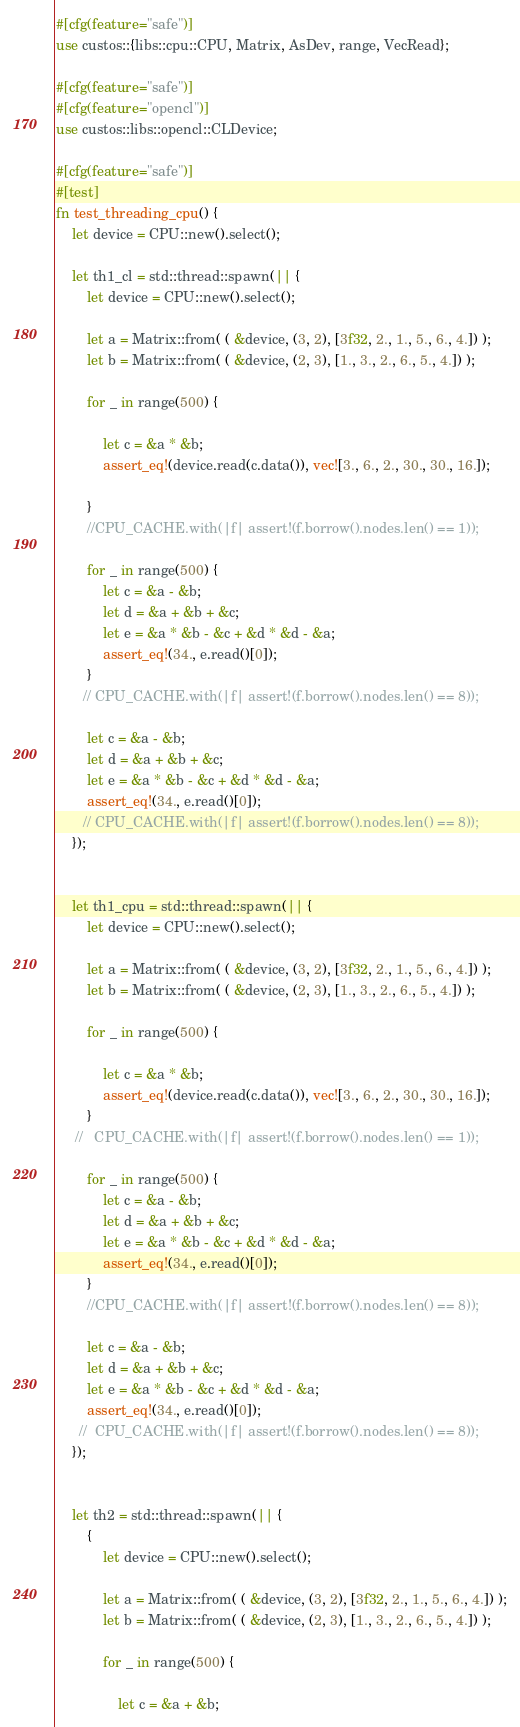<code> <loc_0><loc_0><loc_500><loc_500><_Rust_>#[cfg(feature="safe")]
use custos::{libs::cpu::CPU, Matrix, AsDev, range, VecRead};

#[cfg(feature="safe")]
#[cfg(feature="opencl")]
use custos::libs::opencl::CLDevice;

#[cfg(feature="safe")]
#[test]
fn test_threading_cpu() {
    let device = CPU::new().select();

    let th1_cl = std::thread::spawn(|| {
        let device = CPU::new().select();
        
        let a = Matrix::from( ( &device, (3, 2), [3f32, 2., 1., 5., 6., 4.]) );
        let b = Matrix::from( ( &device, (2, 3), [1., 3., 2., 6., 5., 4.]) );
        
        for _ in range(500) {
            
            let c = &a * &b;
            assert_eq!(device.read(c.data()), vec![3., 6., 2., 30., 30., 16.]);

        }
        //CPU_CACHE.with(|f| assert!(f.borrow().nodes.len() == 1));

        for _ in range(500) {
            let c = &a - &b;
            let d = &a + &b + &c;
            let e = &a * &b - &c + &d * &d - &a;
            assert_eq!(34., e.read()[0]);    
        }
       // CPU_CACHE.with(|f| assert!(f.borrow().nodes.len() == 8));

        let c = &a - &b;
        let d = &a + &b + &c;
        let e = &a * &b - &c + &d * &d - &a;
        assert_eq!(34., e.read()[0]);
       // CPU_CACHE.with(|f| assert!(f.borrow().nodes.len() == 8));
    });


    let th1_cpu = std::thread::spawn(|| {
        let device = CPU::new().select();
        
        let a = Matrix::from( ( &device, (3, 2), [3f32, 2., 1., 5., 6., 4.]) );
        let b = Matrix::from( ( &device, (2, 3), [1., 3., 2., 6., 5., 4.]) );
        
        for _ in range(500) {
            
            let c = &a * &b;
            assert_eq!(device.read(c.data()), vec![3., 6., 2., 30., 30., 16.]);
        }
     //   CPU_CACHE.with(|f| assert!(f.borrow().nodes.len() == 1));

        for _ in range(500) {
            let c = &a - &b;
            let d = &a + &b + &c;
            let e = &a * &b - &c + &d * &d - &a;
            assert_eq!(34., e.read()[0]);    
        }
        //CPU_CACHE.with(|f| assert!(f.borrow().nodes.len() == 8));

        let c = &a - &b;
        let d = &a + &b + &c;
        let e = &a * &b - &c + &d * &d - &a;
        assert_eq!(34., e.read()[0]);
      //  CPU_CACHE.with(|f| assert!(f.borrow().nodes.len() == 8));
    });


    let th2 = std::thread::spawn(|| {
        {
            let device = CPU::new().select();
            
            let a = Matrix::from( ( &device, (3, 2), [3f32, 2., 1., 5., 6., 4.]) );
            let b = Matrix::from( ( &device, (2, 3), [1., 3., 2., 6., 5., 4.]) );
            
            for _ in range(500) {
                
                let c = &a + &b;</code> 